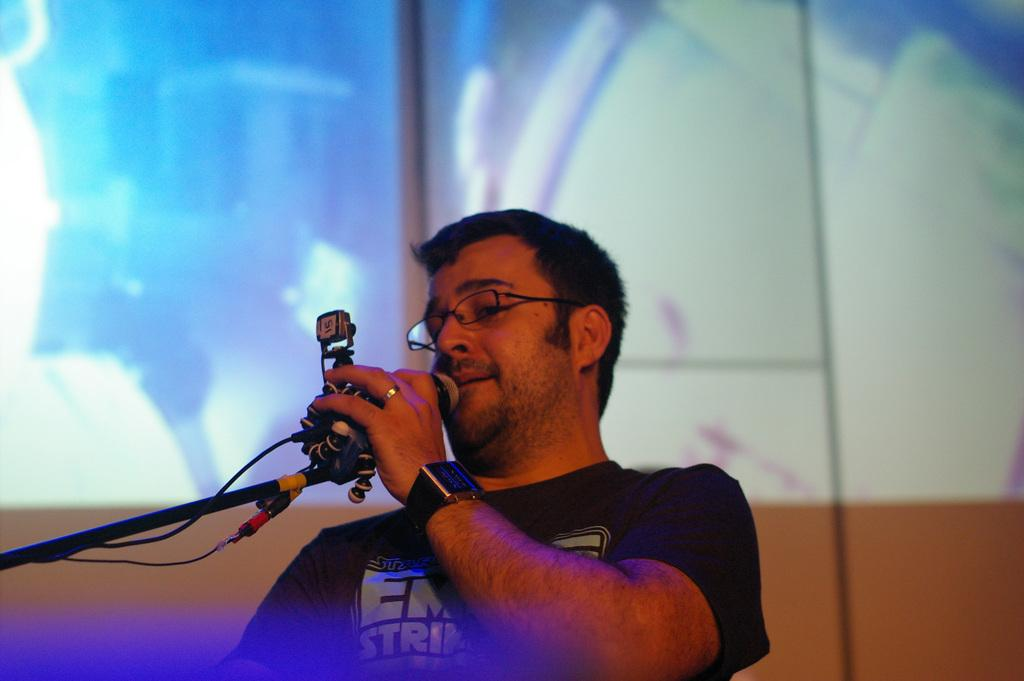Who is the person in the image? There is a man in the image. What is the man wearing? The man is wearing a black t-shirt. What is the man doing in the image? The man is standing and singing into a microphone. What can be seen in the background of the image? There is a projector screen in the background. How many oranges are on the page in the image? There are no oranges or pages present in the image. 